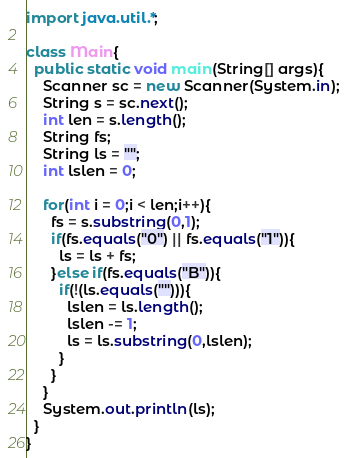Convert code to text. <code><loc_0><loc_0><loc_500><loc_500><_Java_>import java.util.*;

class Main{
  public static void main(String[] args){
    Scanner sc = new Scanner(System.in);
    String s = sc.next();
    int len = s.length();
    String fs;
    String ls = "";
    int lslen = 0;

    for(int i = 0;i < len;i++){
      fs = s.substring(0,1);
      if(fs.equals("0") || fs.equals("1")){
        ls = ls + fs;
      }else if(fs.equals("B")){
        if(!(ls.equals(""))){
          lslen = ls.length();
          lslen -= 1;
          ls = ls.substring(0,lslen);
        }
      }
    }
    System.out.println(ls);
  }
}</code> 